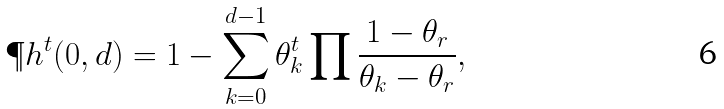<formula> <loc_0><loc_0><loc_500><loc_500>\P h ^ { t } ( 0 , d ) = 1 - \sum _ { k = 0 } ^ { d - 1 } \theta ^ { t } _ { k } \prod \frac { 1 - \theta _ { r } } { \theta _ { k } - \theta _ { r } } ,</formula> 